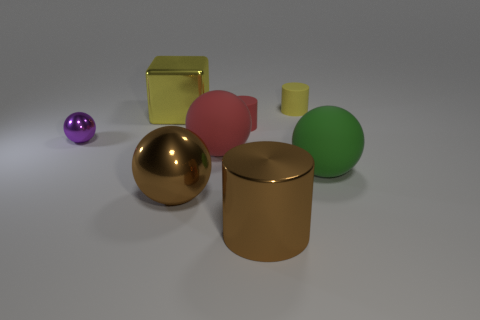Subtract all yellow spheres. Subtract all yellow blocks. How many spheres are left? 4 Add 1 brown shiny spheres. How many objects exist? 9 Subtract all blocks. How many objects are left? 7 Add 3 yellow blocks. How many yellow blocks exist? 4 Subtract 1 brown cylinders. How many objects are left? 7 Subtract all big purple balls. Subtract all big metal things. How many objects are left? 5 Add 2 tiny rubber things. How many tiny rubber things are left? 4 